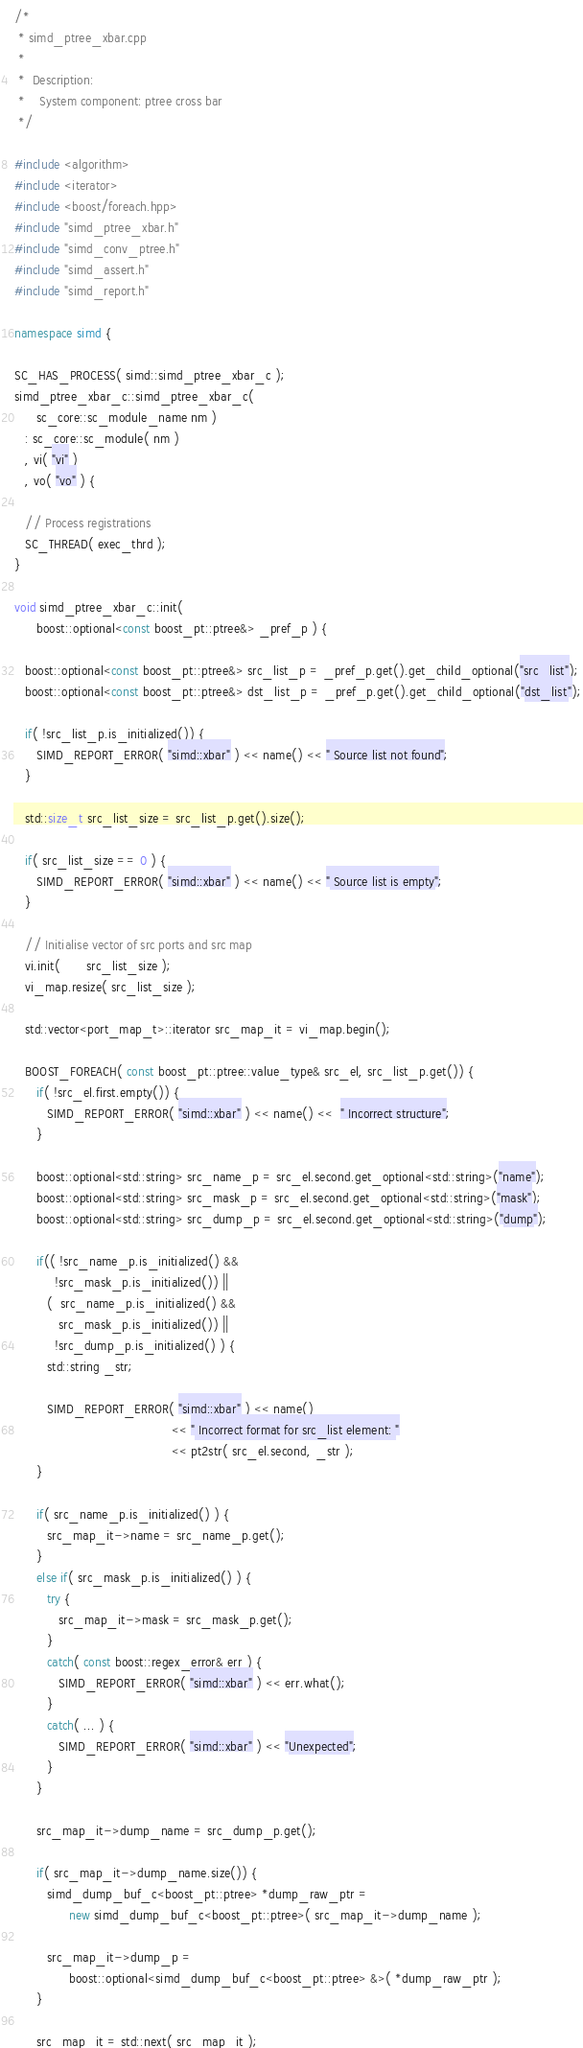Convert code to text. <code><loc_0><loc_0><loc_500><loc_500><_C++_>/*
 * simd_ptree_xbar.cpp
 *
 *  Description:
 *    System component: ptree cross bar
 */

#include <algorithm>
#include <iterator>
#include <boost/foreach.hpp>
#include "simd_ptree_xbar.h"
#include "simd_conv_ptree.h"
#include "simd_assert.h"
#include "simd_report.h"

namespace simd {

SC_HAS_PROCESS( simd::simd_ptree_xbar_c );
simd_ptree_xbar_c::simd_ptree_xbar_c(
      sc_core::sc_module_name nm )
   : sc_core::sc_module( nm )
   , vi( "vi" )
   , vo( "vo" ) {

   // Process registrations
   SC_THREAD( exec_thrd );
}

void simd_ptree_xbar_c::init(
      boost::optional<const boost_pt::ptree&> _pref_p ) {

   boost::optional<const boost_pt::ptree&> src_list_p = _pref_p.get().get_child_optional("src_list");
   boost::optional<const boost_pt::ptree&> dst_list_p = _pref_p.get().get_child_optional("dst_list");

   if( !src_list_p.is_initialized()) {
      SIMD_REPORT_ERROR( "simd::xbar" ) << name() << " Source list not found";
   }

   std::size_t src_list_size = src_list_p.get().size();

   if( src_list_size == 0 ) {
      SIMD_REPORT_ERROR( "simd::xbar" ) << name() << " Source list is empty";
   }

   // Initialise vector of src ports and src map
   vi.init(       src_list_size );
   vi_map.resize( src_list_size );

   std::vector<port_map_t>::iterator src_map_it = vi_map.begin();

   BOOST_FOREACH( const boost_pt::ptree::value_type& src_el, src_list_p.get()) {
      if( !src_el.first.empty()) {
         SIMD_REPORT_ERROR( "simd::xbar" ) << name() <<  " Incorrect structure";
      }

      boost::optional<std::string> src_name_p = src_el.second.get_optional<std::string>("name");
      boost::optional<std::string> src_mask_p = src_el.second.get_optional<std::string>("mask");
      boost::optional<std::string> src_dump_p = src_el.second.get_optional<std::string>("dump");

      if(( !src_name_p.is_initialized() &&
           !src_mask_p.is_initialized()) ||
         (  src_name_p.is_initialized() &&
            src_mask_p.is_initialized()) ||
           !src_dump_p.is_initialized() ) {
         std::string _str;

         SIMD_REPORT_ERROR( "simd::xbar" ) << name()
                                           << " Incorrect format for src_list element: "
                                           << pt2str( src_el.second, _str );
      }

      if( src_name_p.is_initialized() ) {
         src_map_it->name = src_name_p.get();
      }
      else if( src_mask_p.is_initialized() ) {
         try {
            src_map_it->mask = src_mask_p.get();
         }
         catch( const boost::regex_error& err ) {
            SIMD_REPORT_ERROR( "simd::xbar" ) << err.what();
         }
         catch( ... ) {
            SIMD_REPORT_ERROR( "simd::xbar" ) << "Unexpected";
         }
      }

      src_map_it->dump_name = src_dump_p.get();

      if( src_map_it->dump_name.size()) {
         simd_dump_buf_c<boost_pt::ptree> *dump_raw_ptr =
               new simd_dump_buf_c<boost_pt::ptree>( src_map_it->dump_name );

         src_map_it->dump_p =
               boost::optional<simd_dump_buf_c<boost_pt::ptree> &>( *dump_raw_ptr );
      }

      src_map_it = std::next( src_map_it );</code> 